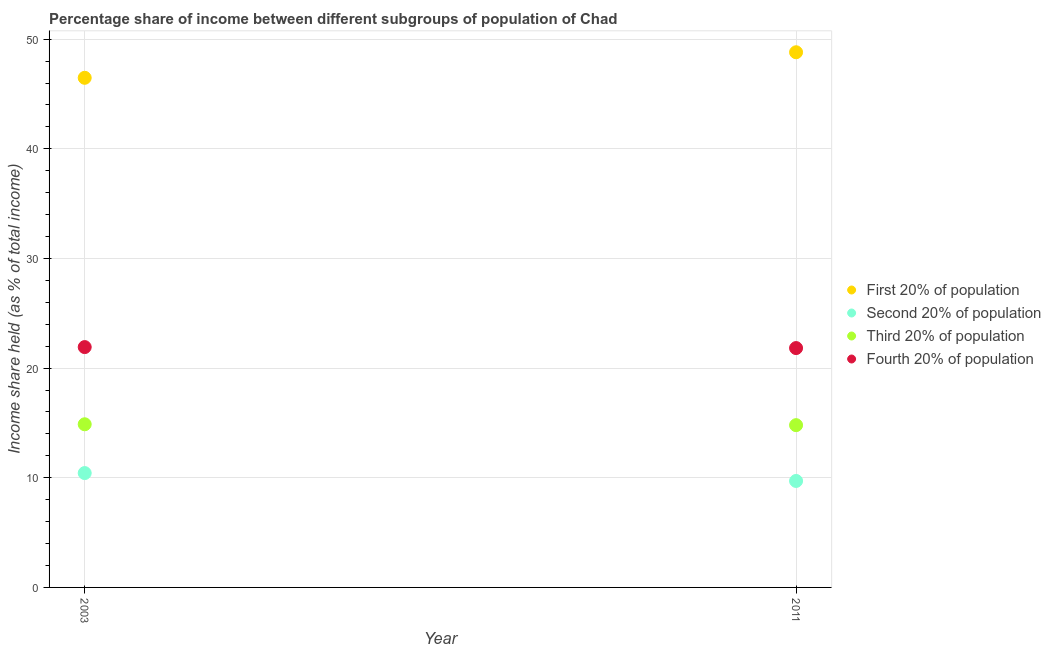How many different coloured dotlines are there?
Offer a very short reply. 4. Is the number of dotlines equal to the number of legend labels?
Give a very brief answer. Yes. What is the share of the income held by fourth 20% of the population in 2003?
Ensure brevity in your answer.  21.92. Across all years, what is the maximum share of the income held by third 20% of the population?
Your answer should be very brief. 14.88. Across all years, what is the minimum share of the income held by first 20% of the population?
Make the answer very short. 46.48. In which year was the share of the income held by third 20% of the population minimum?
Offer a terse response. 2011. What is the total share of the income held by first 20% of the population in the graph?
Your response must be concise. 95.29. What is the difference between the share of the income held by first 20% of the population in 2003 and that in 2011?
Ensure brevity in your answer.  -2.33. What is the difference between the share of the income held by second 20% of the population in 2011 and the share of the income held by first 20% of the population in 2003?
Offer a very short reply. -36.77. What is the average share of the income held by second 20% of the population per year?
Keep it short and to the point. 10.07. In the year 2003, what is the difference between the share of the income held by third 20% of the population and share of the income held by second 20% of the population?
Provide a short and direct response. 4.45. In how many years, is the share of the income held by fourth 20% of the population greater than 34 %?
Offer a terse response. 0. What is the ratio of the share of the income held by second 20% of the population in 2003 to that in 2011?
Provide a short and direct response. 1.07. Is the share of the income held by first 20% of the population in 2003 less than that in 2011?
Give a very brief answer. Yes. In how many years, is the share of the income held by first 20% of the population greater than the average share of the income held by first 20% of the population taken over all years?
Provide a succinct answer. 1. Is it the case that in every year, the sum of the share of the income held by first 20% of the population and share of the income held by second 20% of the population is greater than the share of the income held by third 20% of the population?
Give a very brief answer. Yes. Does the share of the income held by third 20% of the population monotonically increase over the years?
Your answer should be very brief. No. Is the share of the income held by second 20% of the population strictly greater than the share of the income held by first 20% of the population over the years?
Ensure brevity in your answer.  No. Is the share of the income held by third 20% of the population strictly less than the share of the income held by first 20% of the population over the years?
Give a very brief answer. Yes. Are the values on the major ticks of Y-axis written in scientific E-notation?
Make the answer very short. No. Where does the legend appear in the graph?
Your answer should be very brief. Center right. How are the legend labels stacked?
Provide a short and direct response. Vertical. What is the title of the graph?
Your answer should be compact. Percentage share of income between different subgroups of population of Chad. What is the label or title of the Y-axis?
Your response must be concise. Income share held (as % of total income). What is the Income share held (as % of total income) of First 20% of population in 2003?
Offer a terse response. 46.48. What is the Income share held (as % of total income) of Second 20% of population in 2003?
Make the answer very short. 10.43. What is the Income share held (as % of total income) in Third 20% of population in 2003?
Keep it short and to the point. 14.88. What is the Income share held (as % of total income) in Fourth 20% of population in 2003?
Offer a terse response. 21.92. What is the Income share held (as % of total income) of First 20% of population in 2011?
Your answer should be compact. 48.81. What is the Income share held (as % of total income) in Second 20% of population in 2011?
Keep it short and to the point. 9.71. What is the Income share held (as % of total income) of Third 20% of population in 2011?
Your answer should be very brief. 14.8. What is the Income share held (as % of total income) of Fourth 20% of population in 2011?
Your response must be concise. 21.83. Across all years, what is the maximum Income share held (as % of total income) of First 20% of population?
Ensure brevity in your answer.  48.81. Across all years, what is the maximum Income share held (as % of total income) in Second 20% of population?
Make the answer very short. 10.43. Across all years, what is the maximum Income share held (as % of total income) of Third 20% of population?
Keep it short and to the point. 14.88. Across all years, what is the maximum Income share held (as % of total income) in Fourth 20% of population?
Offer a very short reply. 21.92. Across all years, what is the minimum Income share held (as % of total income) in First 20% of population?
Make the answer very short. 46.48. Across all years, what is the minimum Income share held (as % of total income) in Second 20% of population?
Give a very brief answer. 9.71. Across all years, what is the minimum Income share held (as % of total income) in Third 20% of population?
Make the answer very short. 14.8. Across all years, what is the minimum Income share held (as % of total income) of Fourth 20% of population?
Provide a short and direct response. 21.83. What is the total Income share held (as % of total income) of First 20% of population in the graph?
Provide a succinct answer. 95.29. What is the total Income share held (as % of total income) in Second 20% of population in the graph?
Make the answer very short. 20.14. What is the total Income share held (as % of total income) of Third 20% of population in the graph?
Provide a succinct answer. 29.68. What is the total Income share held (as % of total income) of Fourth 20% of population in the graph?
Your response must be concise. 43.75. What is the difference between the Income share held (as % of total income) of First 20% of population in 2003 and that in 2011?
Your response must be concise. -2.33. What is the difference between the Income share held (as % of total income) in Second 20% of population in 2003 and that in 2011?
Provide a succinct answer. 0.72. What is the difference between the Income share held (as % of total income) in Fourth 20% of population in 2003 and that in 2011?
Your answer should be very brief. 0.09. What is the difference between the Income share held (as % of total income) in First 20% of population in 2003 and the Income share held (as % of total income) in Second 20% of population in 2011?
Give a very brief answer. 36.77. What is the difference between the Income share held (as % of total income) in First 20% of population in 2003 and the Income share held (as % of total income) in Third 20% of population in 2011?
Offer a terse response. 31.68. What is the difference between the Income share held (as % of total income) in First 20% of population in 2003 and the Income share held (as % of total income) in Fourth 20% of population in 2011?
Keep it short and to the point. 24.65. What is the difference between the Income share held (as % of total income) in Second 20% of population in 2003 and the Income share held (as % of total income) in Third 20% of population in 2011?
Your response must be concise. -4.37. What is the difference between the Income share held (as % of total income) in Third 20% of population in 2003 and the Income share held (as % of total income) in Fourth 20% of population in 2011?
Keep it short and to the point. -6.95. What is the average Income share held (as % of total income) in First 20% of population per year?
Your answer should be very brief. 47.65. What is the average Income share held (as % of total income) of Second 20% of population per year?
Give a very brief answer. 10.07. What is the average Income share held (as % of total income) in Third 20% of population per year?
Your answer should be very brief. 14.84. What is the average Income share held (as % of total income) in Fourth 20% of population per year?
Provide a short and direct response. 21.88. In the year 2003, what is the difference between the Income share held (as % of total income) of First 20% of population and Income share held (as % of total income) of Second 20% of population?
Offer a terse response. 36.05. In the year 2003, what is the difference between the Income share held (as % of total income) of First 20% of population and Income share held (as % of total income) of Third 20% of population?
Your response must be concise. 31.6. In the year 2003, what is the difference between the Income share held (as % of total income) in First 20% of population and Income share held (as % of total income) in Fourth 20% of population?
Your answer should be compact. 24.56. In the year 2003, what is the difference between the Income share held (as % of total income) of Second 20% of population and Income share held (as % of total income) of Third 20% of population?
Provide a short and direct response. -4.45. In the year 2003, what is the difference between the Income share held (as % of total income) in Second 20% of population and Income share held (as % of total income) in Fourth 20% of population?
Provide a short and direct response. -11.49. In the year 2003, what is the difference between the Income share held (as % of total income) in Third 20% of population and Income share held (as % of total income) in Fourth 20% of population?
Your answer should be compact. -7.04. In the year 2011, what is the difference between the Income share held (as % of total income) in First 20% of population and Income share held (as % of total income) in Second 20% of population?
Your answer should be compact. 39.1. In the year 2011, what is the difference between the Income share held (as % of total income) of First 20% of population and Income share held (as % of total income) of Third 20% of population?
Provide a succinct answer. 34.01. In the year 2011, what is the difference between the Income share held (as % of total income) of First 20% of population and Income share held (as % of total income) of Fourth 20% of population?
Your response must be concise. 26.98. In the year 2011, what is the difference between the Income share held (as % of total income) in Second 20% of population and Income share held (as % of total income) in Third 20% of population?
Provide a succinct answer. -5.09. In the year 2011, what is the difference between the Income share held (as % of total income) in Second 20% of population and Income share held (as % of total income) in Fourth 20% of population?
Give a very brief answer. -12.12. In the year 2011, what is the difference between the Income share held (as % of total income) of Third 20% of population and Income share held (as % of total income) of Fourth 20% of population?
Give a very brief answer. -7.03. What is the ratio of the Income share held (as % of total income) in First 20% of population in 2003 to that in 2011?
Your answer should be very brief. 0.95. What is the ratio of the Income share held (as % of total income) of Second 20% of population in 2003 to that in 2011?
Your answer should be compact. 1.07. What is the ratio of the Income share held (as % of total income) of Third 20% of population in 2003 to that in 2011?
Make the answer very short. 1.01. What is the difference between the highest and the second highest Income share held (as % of total income) of First 20% of population?
Your answer should be compact. 2.33. What is the difference between the highest and the second highest Income share held (as % of total income) in Second 20% of population?
Your answer should be compact. 0.72. What is the difference between the highest and the second highest Income share held (as % of total income) of Third 20% of population?
Give a very brief answer. 0.08. What is the difference between the highest and the second highest Income share held (as % of total income) in Fourth 20% of population?
Provide a succinct answer. 0.09. What is the difference between the highest and the lowest Income share held (as % of total income) in First 20% of population?
Give a very brief answer. 2.33. What is the difference between the highest and the lowest Income share held (as % of total income) of Second 20% of population?
Offer a terse response. 0.72. What is the difference between the highest and the lowest Income share held (as % of total income) in Third 20% of population?
Keep it short and to the point. 0.08. What is the difference between the highest and the lowest Income share held (as % of total income) in Fourth 20% of population?
Offer a terse response. 0.09. 